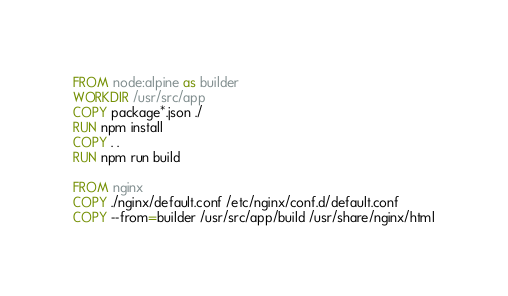Convert code to text. <code><loc_0><loc_0><loc_500><loc_500><_Dockerfile_>FROM node:alpine as builder
WORKDIR /usr/src/app
COPY package*.json ./
RUN npm install
COPY . .
RUN npm run build

FROM nginx
COPY ./nginx/default.conf /etc/nginx/conf.d/default.conf
COPY --from=builder /usr/src/app/build /usr/share/nginx/html
</code> 